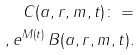Convert formula to latex. <formula><loc_0><loc_0><loc_500><loc_500>C ( a , r , m , t ) \colon = \\ , e ^ { M ( t ) } \, B ( a , r , m , t ) .</formula> 